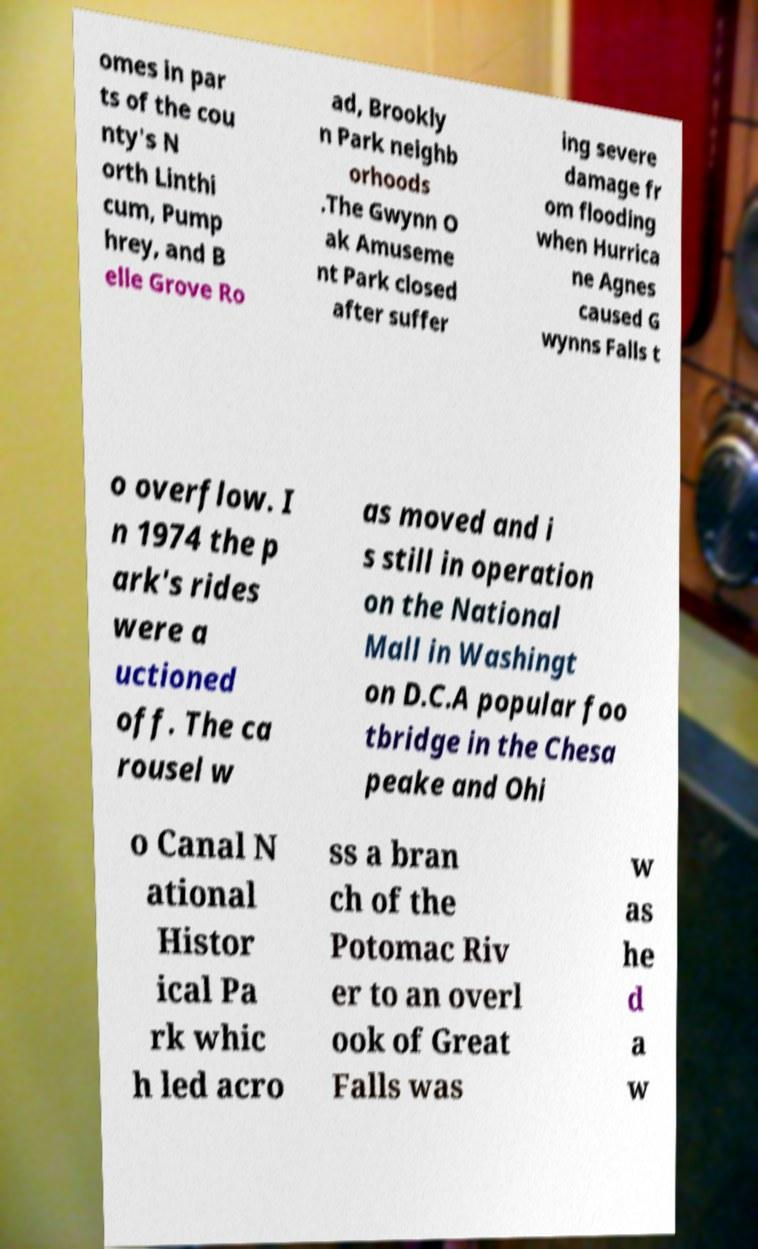Could you extract and type out the text from this image? omes in par ts of the cou nty's N orth Linthi cum, Pump hrey, and B elle Grove Ro ad, Brookly n Park neighb orhoods .The Gwynn O ak Amuseme nt Park closed after suffer ing severe damage fr om flooding when Hurrica ne Agnes caused G wynns Falls t o overflow. I n 1974 the p ark's rides were a uctioned off. The ca rousel w as moved and i s still in operation on the National Mall in Washingt on D.C.A popular foo tbridge in the Chesa peake and Ohi o Canal N ational Histor ical Pa rk whic h led acro ss a bran ch of the Potomac Riv er to an overl ook of Great Falls was w as he d a w 